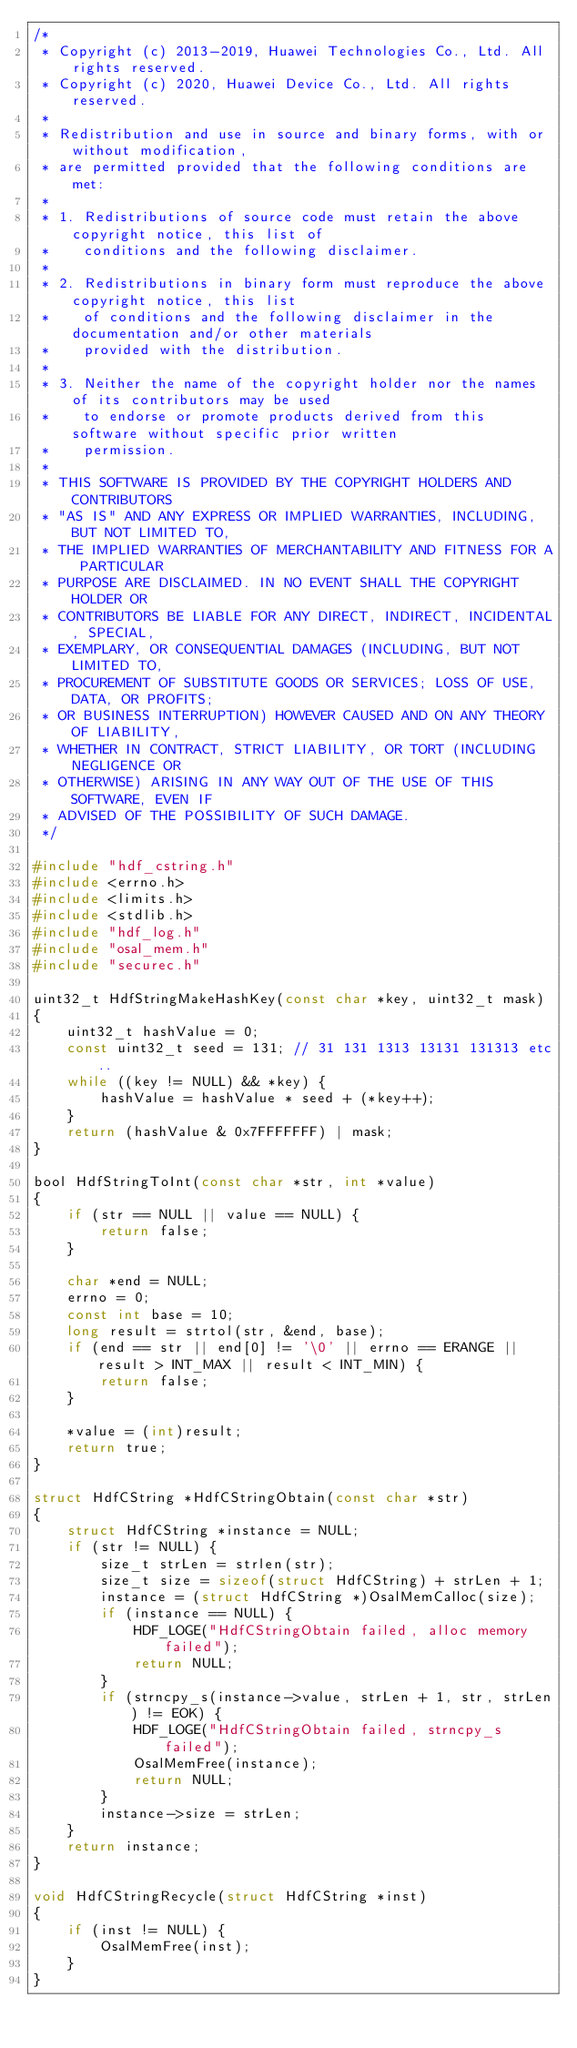Convert code to text. <code><loc_0><loc_0><loc_500><loc_500><_C_>/*
 * Copyright (c) 2013-2019, Huawei Technologies Co., Ltd. All rights reserved.
 * Copyright (c) 2020, Huawei Device Co., Ltd. All rights reserved.
 *
 * Redistribution and use in source and binary forms, with or without modification,
 * are permitted provided that the following conditions are met:
 *
 * 1. Redistributions of source code must retain the above copyright notice, this list of
 *    conditions and the following disclaimer.
 *
 * 2. Redistributions in binary form must reproduce the above copyright notice, this list
 *    of conditions and the following disclaimer in the documentation and/or other materials
 *    provided with the distribution.
 *
 * 3. Neither the name of the copyright holder nor the names of its contributors may be used
 *    to endorse or promote products derived from this software without specific prior written
 *    permission.
 *
 * THIS SOFTWARE IS PROVIDED BY THE COPYRIGHT HOLDERS AND CONTRIBUTORS
 * "AS IS" AND ANY EXPRESS OR IMPLIED WARRANTIES, INCLUDING, BUT NOT LIMITED TO,
 * THE IMPLIED WARRANTIES OF MERCHANTABILITY AND FITNESS FOR A PARTICULAR
 * PURPOSE ARE DISCLAIMED. IN NO EVENT SHALL THE COPYRIGHT HOLDER OR
 * CONTRIBUTORS BE LIABLE FOR ANY DIRECT, INDIRECT, INCIDENTAL, SPECIAL,
 * EXEMPLARY, OR CONSEQUENTIAL DAMAGES (INCLUDING, BUT NOT LIMITED TO,
 * PROCUREMENT OF SUBSTITUTE GOODS OR SERVICES; LOSS OF USE, DATA, OR PROFITS;
 * OR BUSINESS INTERRUPTION) HOWEVER CAUSED AND ON ANY THEORY OF LIABILITY,
 * WHETHER IN CONTRACT, STRICT LIABILITY, OR TORT (INCLUDING NEGLIGENCE OR
 * OTHERWISE) ARISING IN ANY WAY OUT OF THE USE OF THIS SOFTWARE, EVEN IF
 * ADVISED OF THE POSSIBILITY OF SUCH DAMAGE.
 */

#include "hdf_cstring.h"
#include <errno.h>
#include <limits.h>
#include <stdlib.h>
#include "hdf_log.h"
#include "osal_mem.h"
#include "securec.h"

uint32_t HdfStringMakeHashKey(const char *key, uint32_t mask)
{
    uint32_t hashValue = 0;
    const uint32_t seed = 131; // 31 131 1313 13131 131313 etc..
    while ((key != NULL) && *key) {
        hashValue = hashValue * seed + (*key++);
    }
    return (hashValue & 0x7FFFFFFF) | mask;
}

bool HdfStringToInt(const char *str, int *value)
{
    if (str == NULL || value == NULL) {
        return false;
    }

    char *end = NULL;
    errno = 0;
    const int base = 10;
    long result = strtol(str, &end, base);
    if (end == str || end[0] != '\0' || errno == ERANGE || result > INT_MAX || result < INT_MIN) {
        return false;
    }

    *value = (int)result;
    return true;
}

struct HdfCString *HdfCStringObtain(const char *str)
{
    struct HdfCString *instance = NULL;
    if (str != NULL) {
        size_t strLen = strlen(str);
        size_t size = sizeof(struct HdfCString) + strLen + 1;
        instance = (struct HdfCString *)OsalMemCalloc(size);
        if (instance == NULL) {
            HDF_LOGE("HdfCStringObtain failed, alloc memory failed");
            return NULL;
        }
        if (strncpy_s(instance->value, strLen + 1, str, strLen) != EOK) {
            HDF_LOGE("HdfCStringObtain failed, strncpy_s failed");
            OsalMemFree(instance);
            return NULL;
        }
        instance->size = strLen;
    }
    return instance;
}

void HdfCStringRecycle(struct HdfCString *inst)
{
    if (inst != NULL) {
        OsalMemFree(inst);
    }
}
</code> 